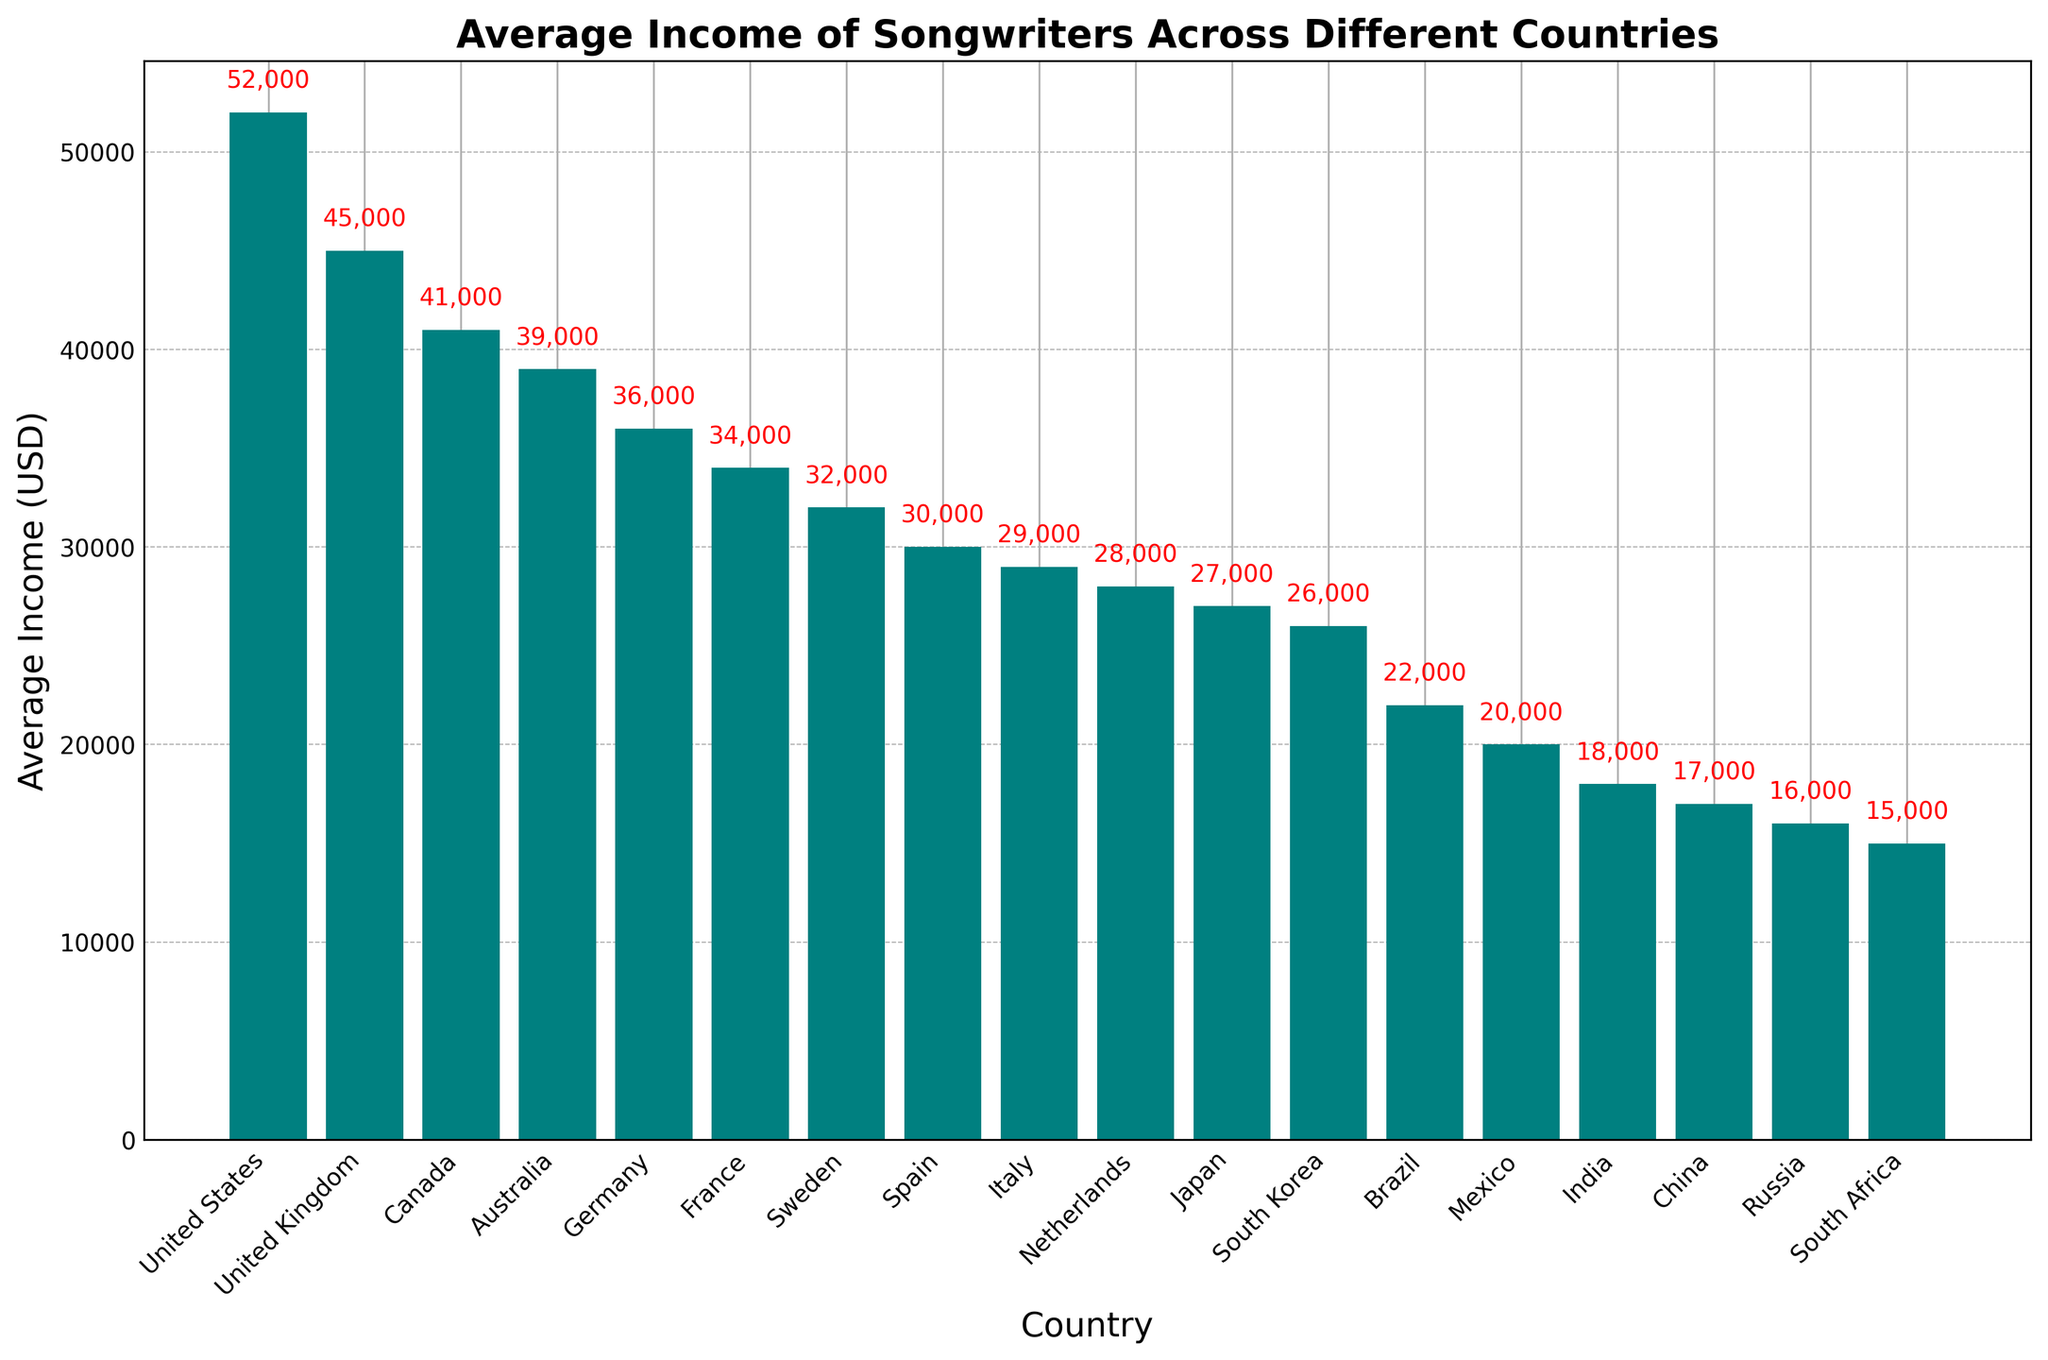Which country has the highest average income for songwriters? From the bar chart, the tallest bar represents the United States, indicating it has the highest average income.
Answer: United States How much more is the average income of songwriters in the United States compared to Canada? The average income in the United States is $52,000, while in Canada it is $41,000. The difference is $52,000 - $41,000 = $11,000.
Answer: $11,000 Which countries have an average income for songwriters that is less than $30,000? From the bar chart, the countries with bars shorter than the $30,000 mark are Italy, Netherlands, Japan, South Korea, Brazil, Mexico, India, China, Russia, and South Africa.
Answer: Italy, Netherlands, Japan, South Korea, Brazil, Mexico, India, China, Russia, South Africa What is the combined average income of songwriters in Germany and France? The average income in Germany is $36,000 and in France is $34,000. Combined, this is $36,000 + $34,000 = $70,000.
Answer: $70,000 Which country has the lowest average income for songwriters, and what is that income? The shortest bar represents South Africa, indicating it has the lowest average income of $15,000.
Answer: South Africa, $15,000 Compare the average income of songwriters in Sweden and Spain. Which country has a higher income and by how much? The average income in Sweden is $32,000, and in Spain, it is $30,000. Sweden has a higher income by $32,000 - $30,000 = $2,000.
Answer: Sweden, $2,000 What is the average income of songwriters in countries with more than one syllable in their names? Combine the average incomes of United States ($52,000), United Kingdom ($45,000), Canada ($41,000), Australia ($39,000), Germany ($36,000), France ($34,000), Sweden ($32,000), Spain ($30,000), Italy ($29,000), Netherlands ($28,000), Japan ($27,000), South Korea ($26,000), Brazil ($22,000), Mexico ($20,000), India ($18,000), China ($17,000), Russia ($16,000), and South Africa ($15,000). The total combined income is $527,000 and there are 18 countries. The average is $527,000 / 18 ≈ $29,278.
Answer: $29,278 How many countries have a songwriter average income higher than $35,000? From the bar chart, the countries with an average income higher than $35,000 are United States, United Kingdom, Canada, Australia, and Germany. This gives us a total of 5 countries.
Answer: 5 What is the income difference between songwriters in the United Kingdom and India? The average income in the United Kingdom is $45,000, and in India, it is $18,000. The difference is $45,000 - $18,000 = $27,000.
Answer: $27,000 